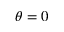Convert formula to latex. <formula><loc_0><loc_0><loc_500><loc_500>\theta = 0</formula> 